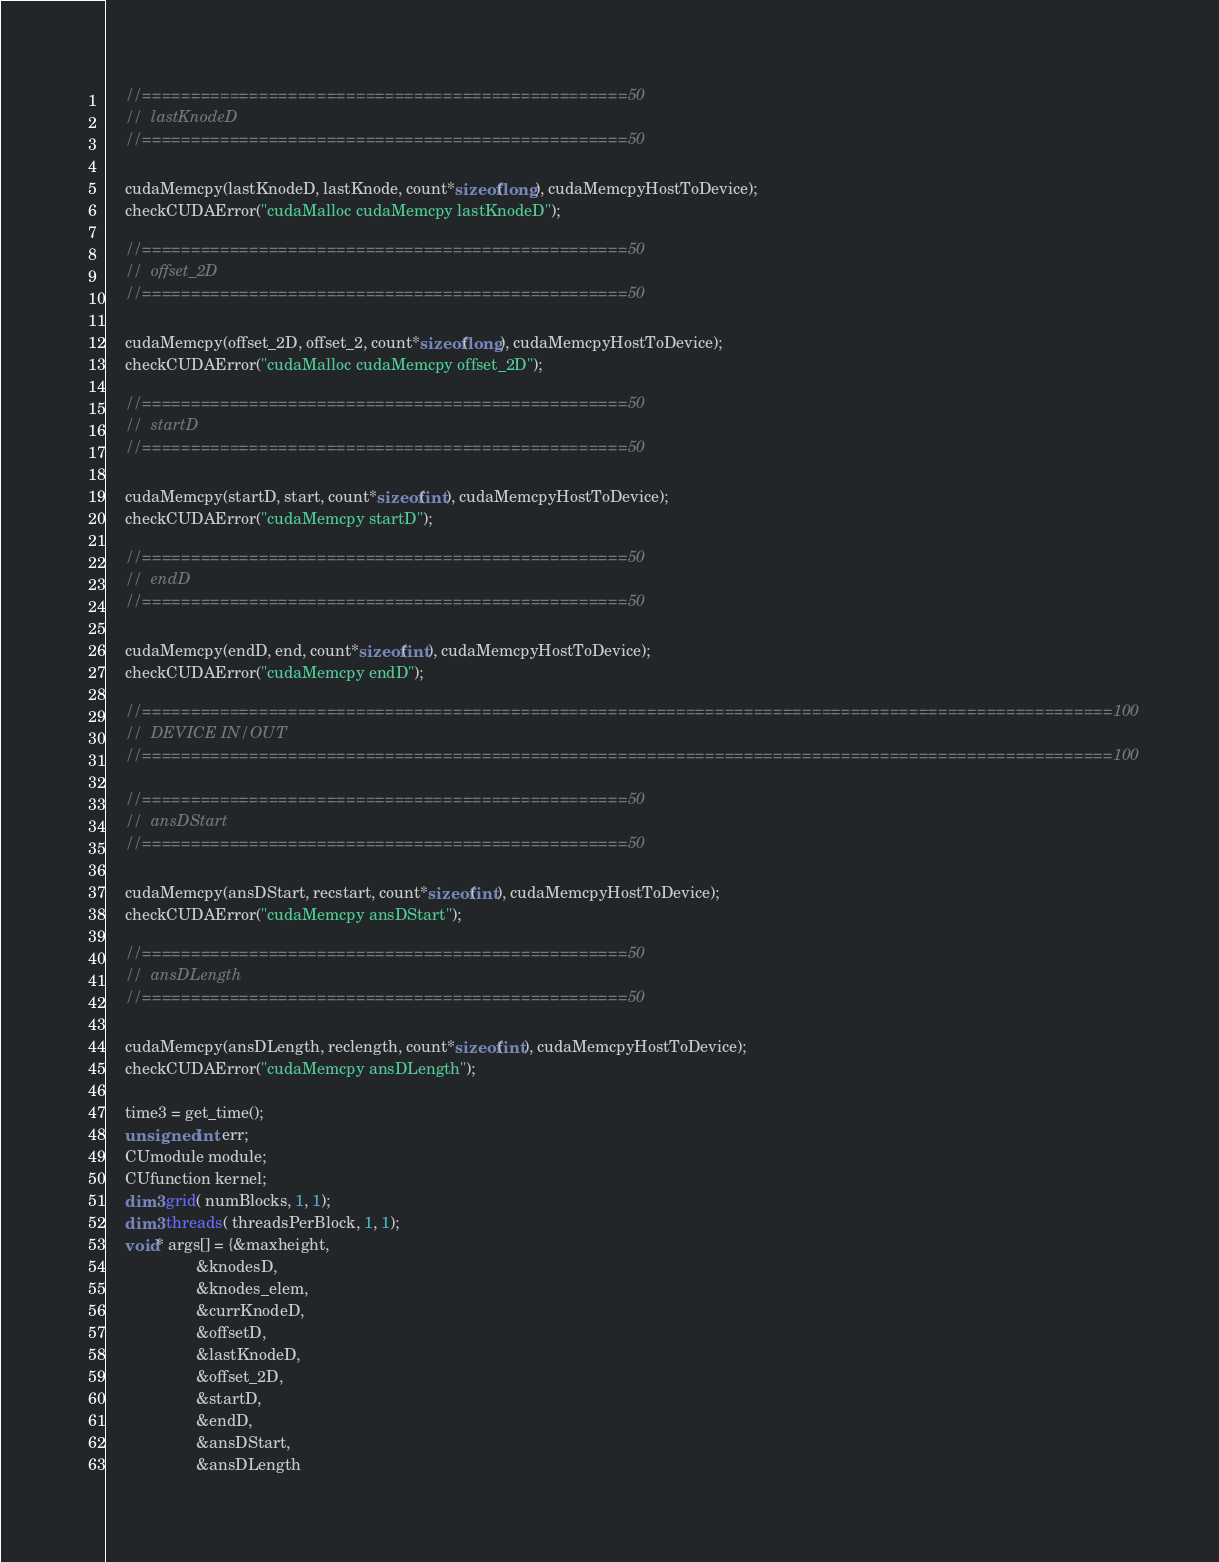Convert code to text. <code><loc_0><loc_0><loc_500><loc_500><_Cuda_>
	//==================================================50
	//	lastKnodeD
	//==================================================50

	cudaMemcpy(lastKnodeD, lastKnode, count*sizeof(long), cudaMemcpyHostToDevice);
	checkCUDAError("cudaMalloc cudaMemcpy lastKnodeD");

	//==================================================50
	//	offset_2D
	//==================================================50

	cudaMemcpy(offset_2D, offset_2, count*sizeof(long), cudaMemcpyHostToDevice);
	checkCUDAError("cudaMalloc cudaMemcpy offset_2D");

	//==================================================50
	//	startD
	//==================================================50

	cudaMemcpy(startD, start, count*sizeof(int), cudaMemcpyHostToDevice);
	checkCUDAError("cudaMemcpy startD");

	//==================================================50
	//	endD
	//==================================================50

	cudaMemcpy(endD, end, count*sizeof(int), cudaMemcpyHostToDevice);
	checkCUDAError("cudaMemcpy endD");

	//====================================================================================================100
	//	DEVICE IN/OUT
	//====================================================================================================100

	//==================================================50
	//	ansDStart
	//==================================================50

	cudaMemcpy(ansDStart, recstart, count*sizeof(int), cudaMemcpyHostToDevice);
	checkCUDAError("cudaMemcpy ansDStart");

	//==================================================50
	//	ansDLength
	//==================================================50

	cudaMemcpy(ansDLength, reclength, count*sizeof(int), cudaMemcpyHostToDevice);
	checkCUDAError("cudaMemcpy ansDLength");

	time3 = get_time();
	unsigned int err;
	CUmodule module;
    CUfunction kernel;
	dim3 grid( numBlocks, 1, 1);
	dim3 threads( threadsPerBlock, 1, 1);
	void* args[] = {&maxheight,
                    &knodesD,
                    &knodes_elem,
                    &currKnodeD,
                    &offsetD,
                    &lastKnodeD,
					&offset_2D,
					&startD,
					&endD,
					&ansDStart,
					&ansDLength</code> 